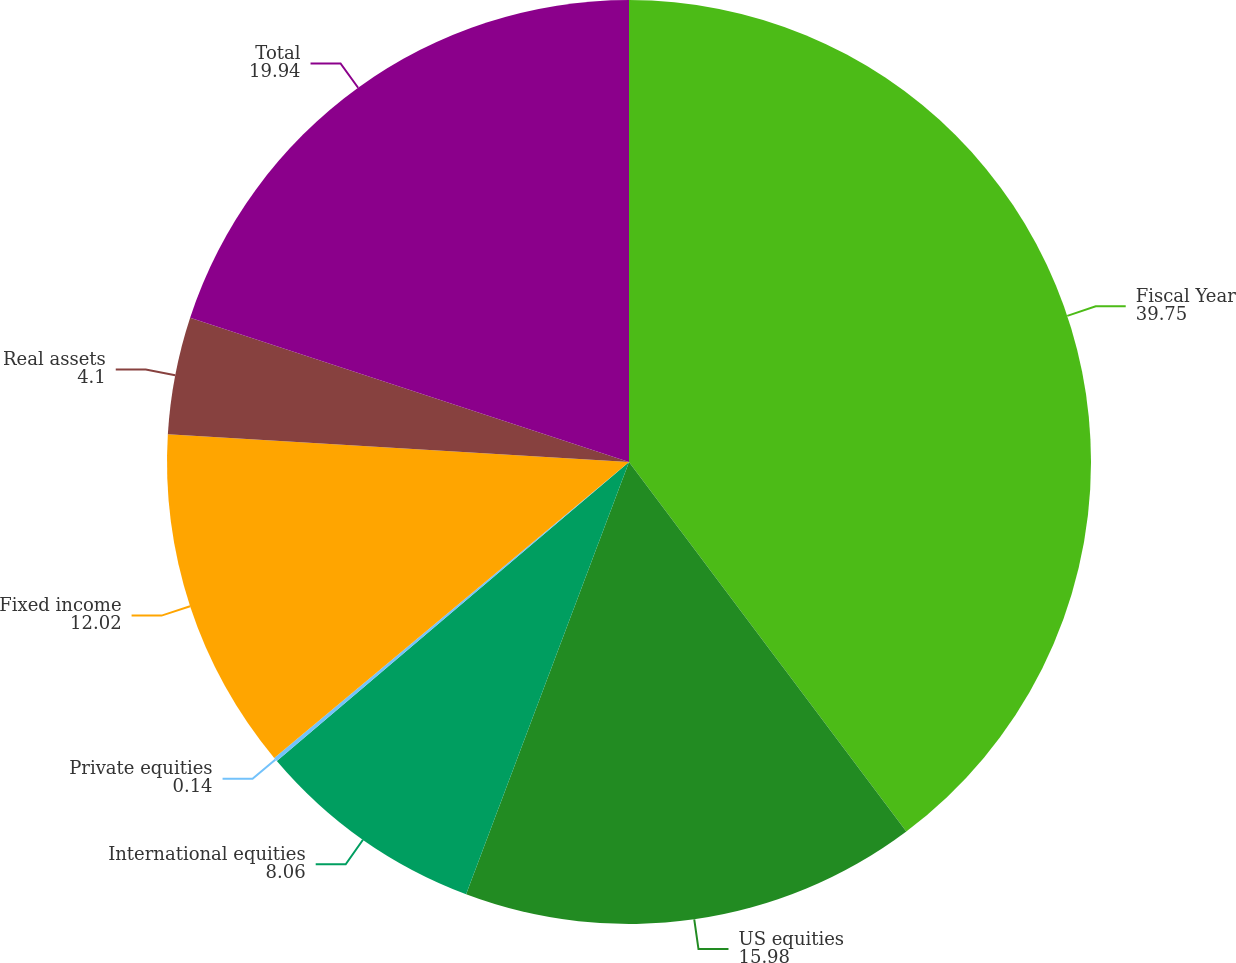<chart> <loc_0><loc_0><loc_500><loc_500><pie_chart><fcel>Fiscal Year<fcel>US equities<fcel>International equities<fcel>Private equities<fcel>Fixed income<fcel>Real assets<fcel>Total<nl><fcel>39.75%<fcel>15.98%<fcel>8.06%<fcel>0.14%<fcel>12.02%<fcel>4.1%<fcel>19.94%<nl></chart> 